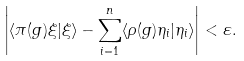<formula> <loc_0><loc_0><loc_500><loc_500>\left | \langle \pi ( g ) \xi | \xi \rangle - \sum _ { i = 1 } ^ { n } \langle \rho ( g ) \eta _ { i } | \eta _ { i } \rangle \right | < \varepsilon .</formula> 